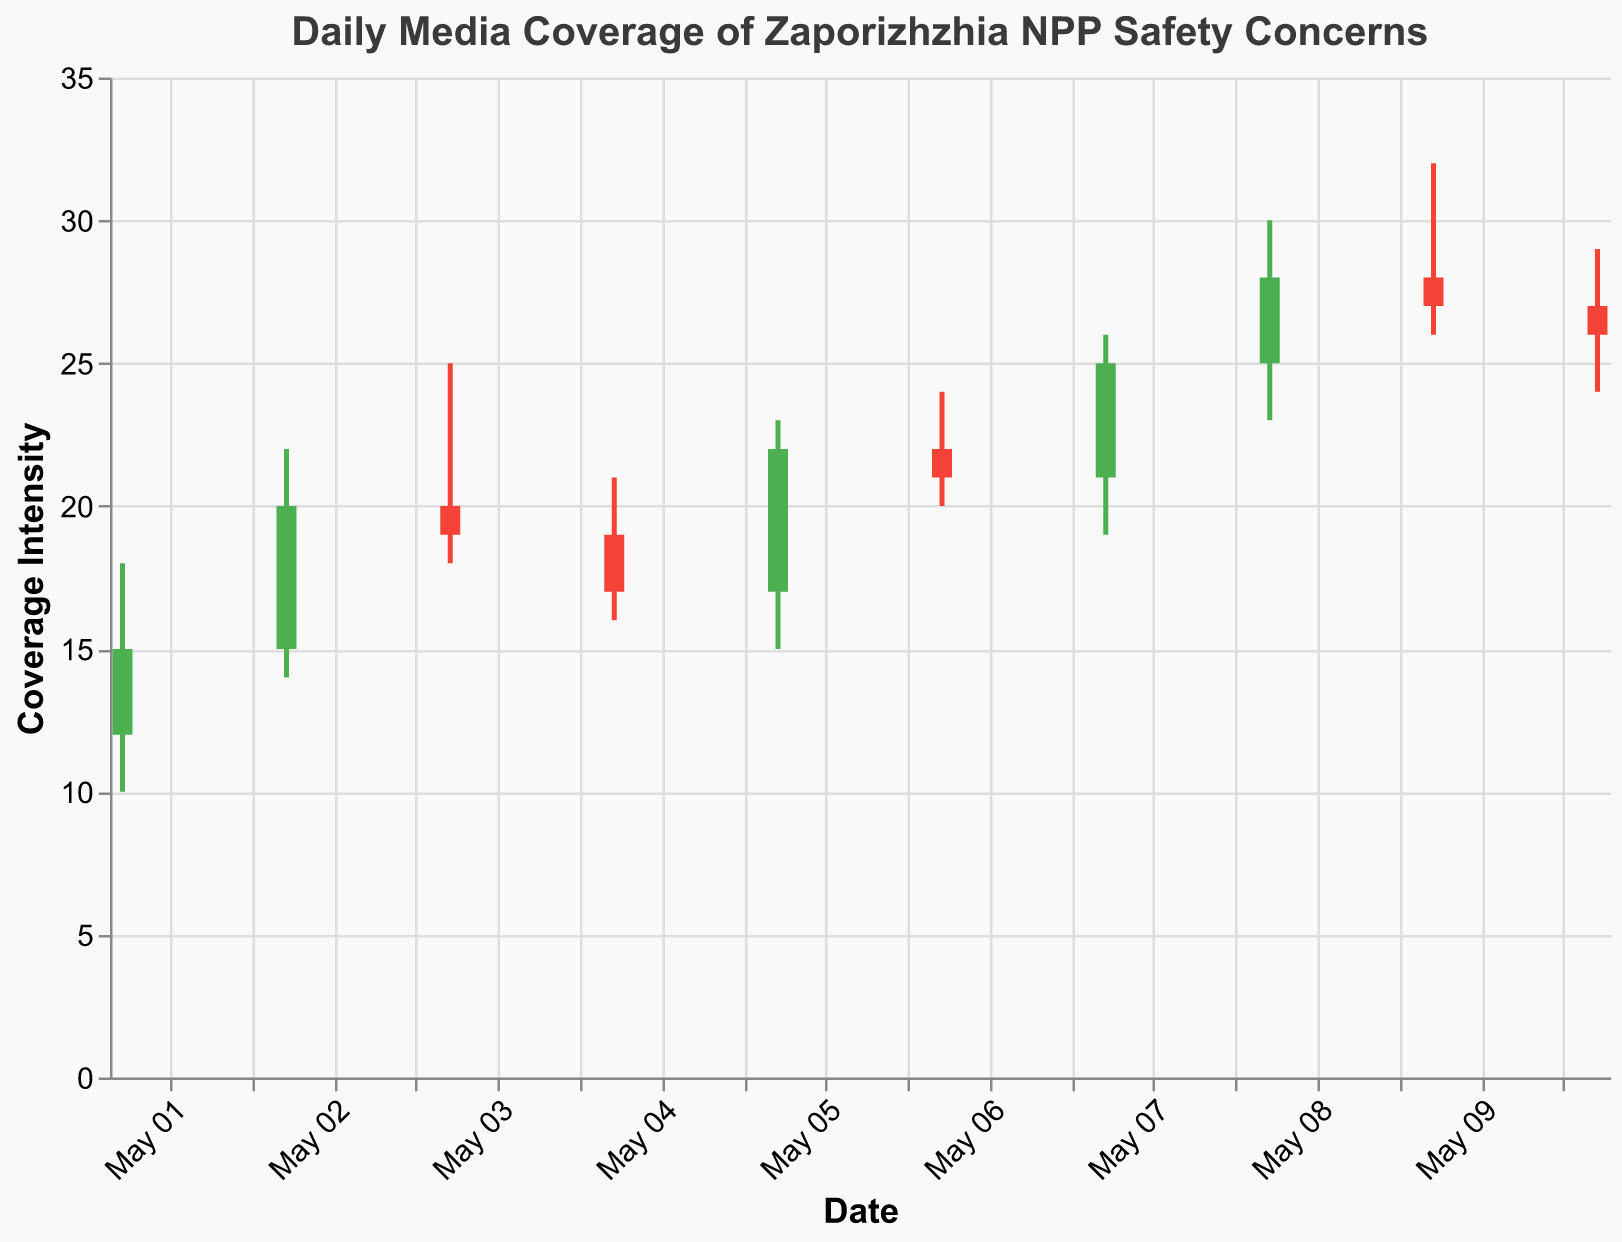What's the maximum coverage intensity recorded in the given period? The maximum coverage intensity is the highest value on the 'High' column. In this dataset, the highest value in the 'High' column is 32 on May 9.
Answer: 32 On which date did the coverage intensity open lower than it closed? Look for green bars as they represent days when the 'Open' value was less than the 'Close' value. The dates with green bars are May 1, May 2, May 5, May 7, May 8.
Answer: May 1, May 2, May 5, May 7, May 8 What is the overall trend of the media coverage from May 1 to May 10? Observe the closing values from May 1 to May 10. The closing values mostly increase over the period (from 15 on May 1 to 26 on May 10), indicating an upward trend despite some fluctuations.
Answer: Upward trend Which date had the largest daily range in coverage intensity? The daily range is calculated by subtracting the 'Low' value from the 'High' value for each day. May 9 has the largest range (32 - 26 = 6).
Answer: May 9 What was the closing value on May 6? Find the date May 6 on the x-axis and read the closing value which is where the bar ends (the height of the green or red bar). The closing value for May 6 is 21.
Answer: 21 How does the coverage intensity on May 8 compare to May 10? Compare both the 'High' and 'Close' values for May 8 and May 10. On May 8, the 'High' value is 30 and the 'Close' value is 28; on May 10, the 'High' is 29 and the 'Close' is 26. Therefore, May 8 values are higher.
Answer: May 8 is higher During which days did coverage start higher than 20 points? Look at the 'Open' values and pick the days where the values are greater than 20. These days are May 6, May 8, May 9, and May 10.
Answer: May 6, May 8, May 9, May 10 What's the difference in the closing values between May 7 and May 9? Subtract the closing value of May 9 (27) from that of May 7 (25). The difference is 27 - 25 = 2.
Answer: 2 